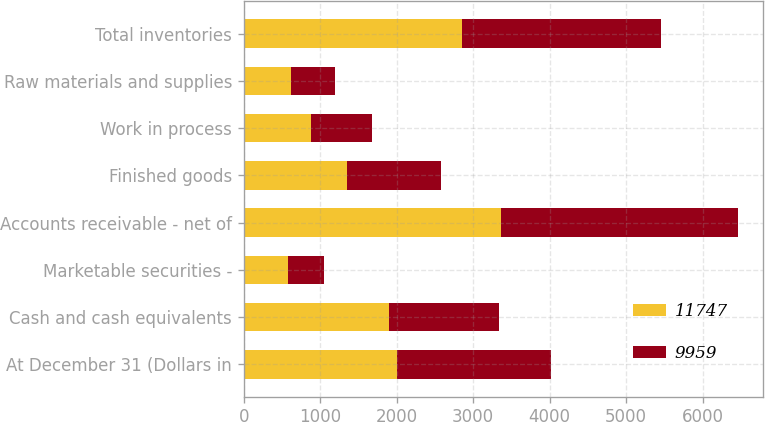Convert chart. <chart><loc_0><loc_0><loc_500><loc_500><stacked_bar_chart><ecel><fcel>At December 31 (Dollars in<fcel>Cash and cash equivalents<fcel>Marketable securities -<fcel>Accounts receivable - net of<fcel>Finished goods<fcel>Work in process<fcel>Raw materials and supplies<fcel>Total inventories<nl><fcel>11747<fcel>2007<fcel>1896<fcel>579<fcel>3362<fcel>1349<fcel>880<fcel>623<fcel>2852<nl><fcel>9959<fcel>2006<fcel>1447<fcel>471<fcel>3102<fcel>1235<fcel>795<fcel>571<fcel>2601<nl></chart> 